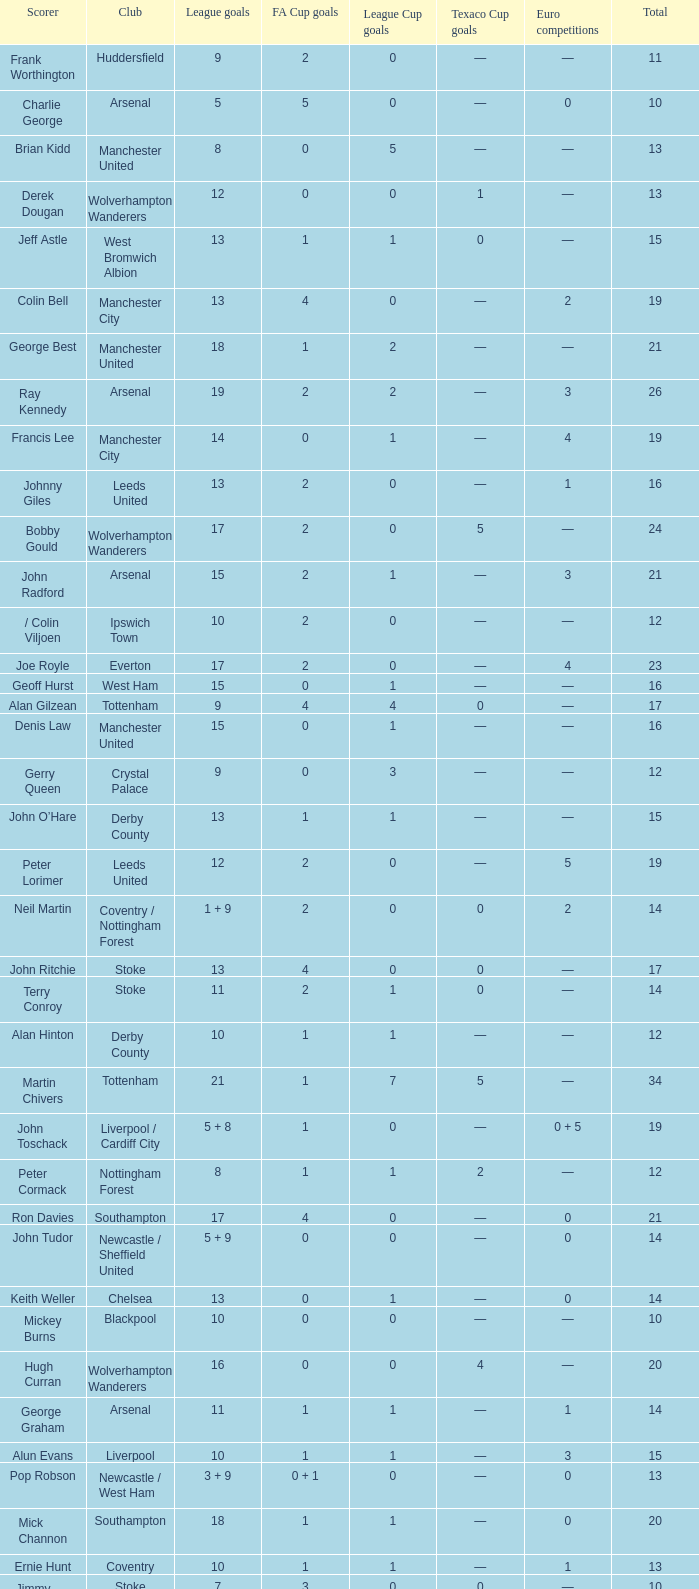What is the lowest League Cup Goals, when Scorer is Denis Law? 1.0. 